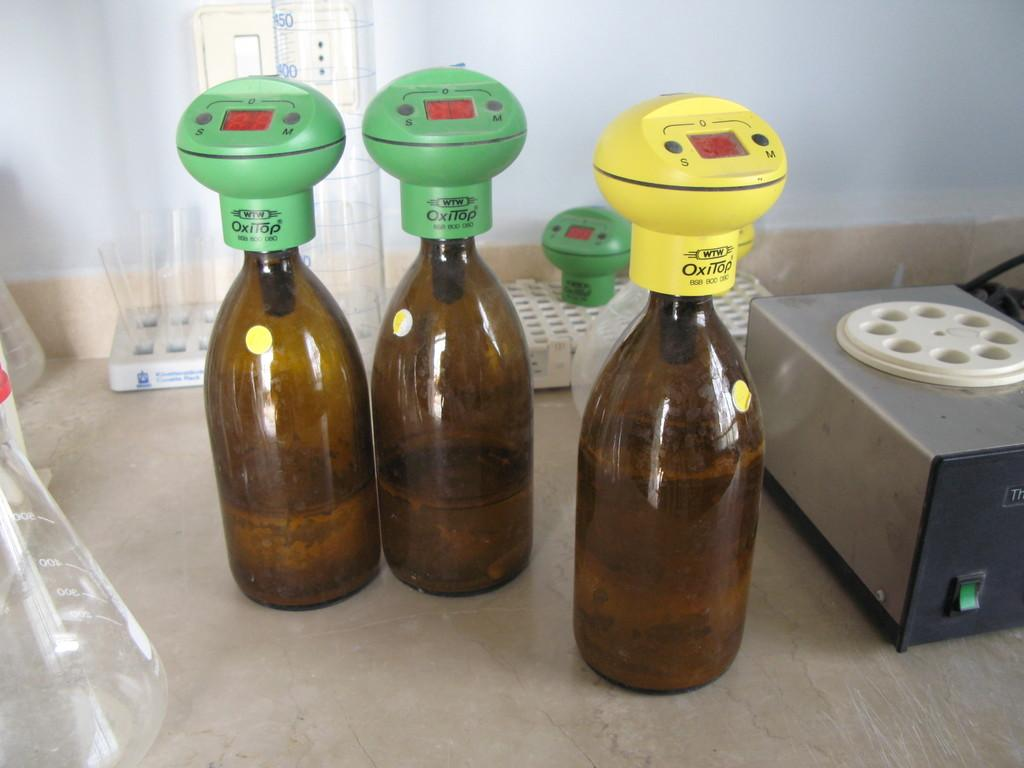What objects can be seen in the image? There are bottles and test tubes visible in the image. What is attached to the bottles? Meters are fixed on the bottles. What type of music can be heard coming from the bottles in the image? There is no music present in the image; it features bottles with meters and test tubes. What scent is associated with the test tubes in the image? There is no mention of a scent in the image; it only shows bottles with meters and test tubes. 